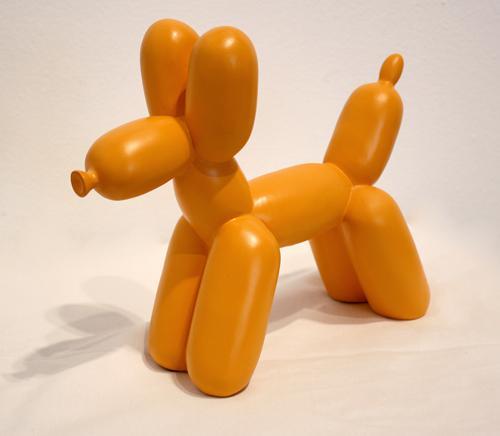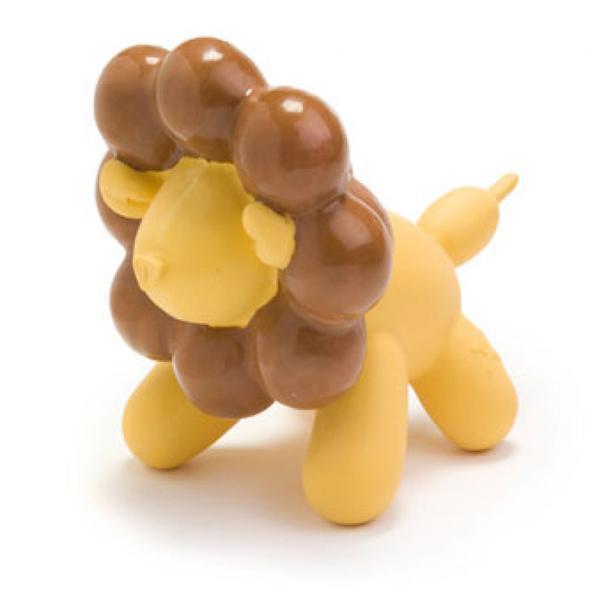The first image is the image on the left, the second image is the image on the right. Evaluate the accuracy of this statement regarding the images: "One of the balloons is the shape of a lion.". Is it true? Answer yes or no. Yes. 